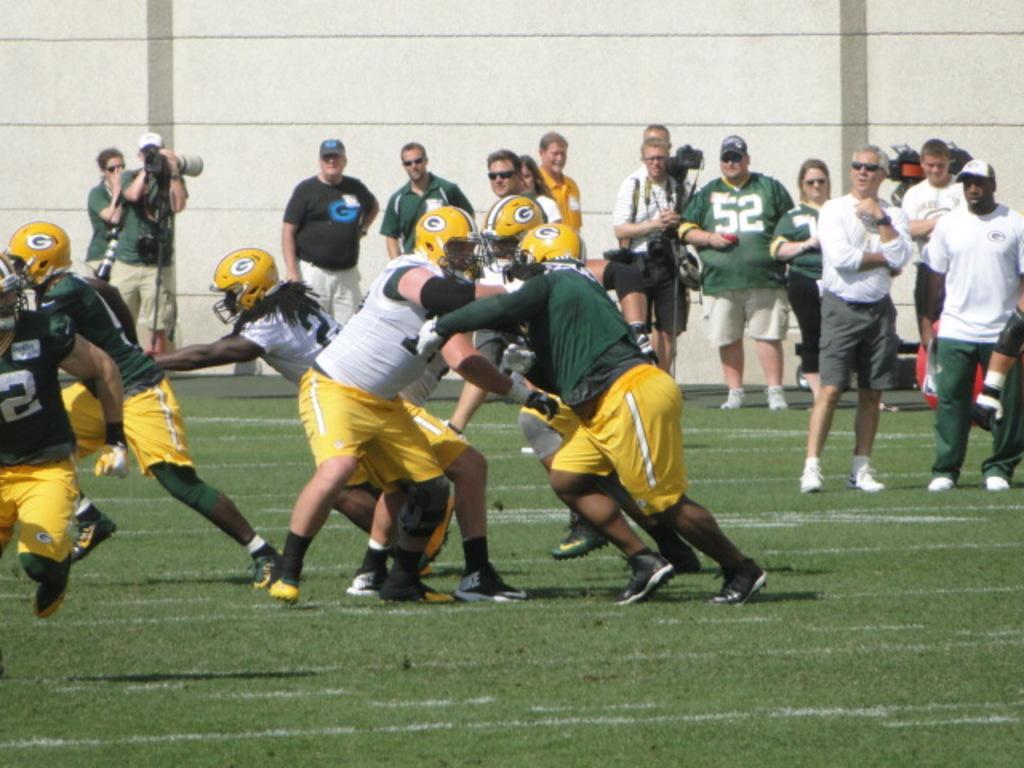How would you summarize this image in a sentence or two? In the middle few men are running, they wore yellow color helmets, shorts. In the right side 2 men are standing, they wore white color t-shirts. Few other people are standing and observing this. 